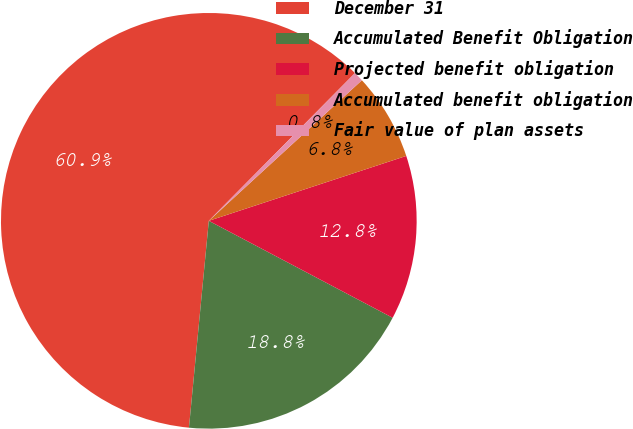Convert chart. <chart><loc_0><loc_0><loc_500><loc_500><pie_chart><fcel>December 31<fcel>Accumulated Benefit Obligation<fcel>Projected benefit obligation<fcel>Accumulated benefit obligation<fcel>Fair value of plan assets<nl><fcel>60.9%<fcel>18.8%<fcel>12.78%<fcel>6.77%<fcel>0.76%<nl></chart> 